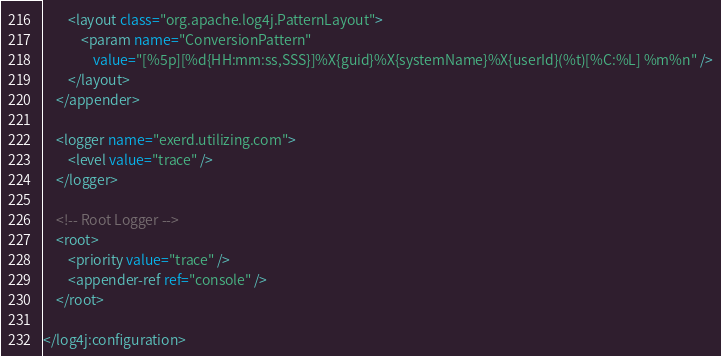Convert code to text. <code><loc_0><loc_0><loc_500><loc_500><_XML_>		<layout class="org.apache.log4j.PatternLayout">
			<param name="ConversionPattern"
				value="[%5p][%d{HH:mm:ss,SSS}]%X{guid}%X{systemName}%X{userId}(%t)[%C:%L] %m%n" />
		</layout>
	</appender>
	
	<logger name="exerd.utilizing.com">
		<level value="trace" />
	</logger>

	<!-- Root Logger -->
	<root>
		<priority value="trace" />
		<appender-ref ref="console" />
	</root>

</log4j:configuration>
</code> 